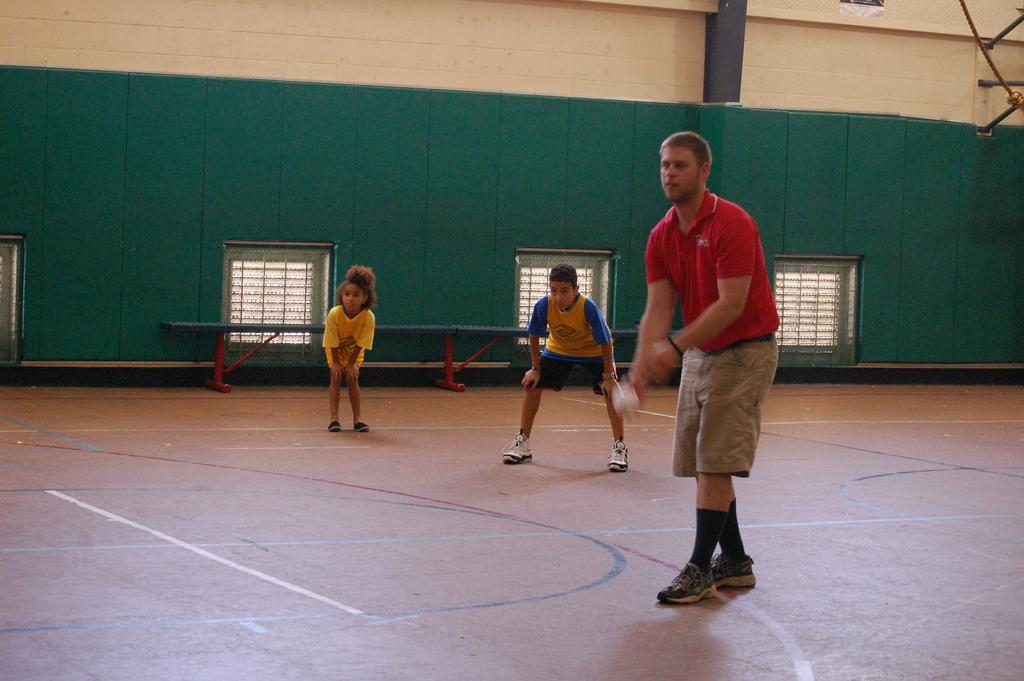What type of structure is present in the image? There is a house in the image. What feature can be seen on the house? The house has windows. How many people are in the image? There are three people in the image. Can you describe the position of one of the individuals? One man is standing in the front. What is the man wearing? The man is wearing a red color t-shirt. What is the man holding? The man is holding a white color ball. What type of crayon is the man using to draw on the wall in the image? There is no crayon or drawing on the wall present in the image. How many sticks are visible in the image? There are no sticks visible in the image. 